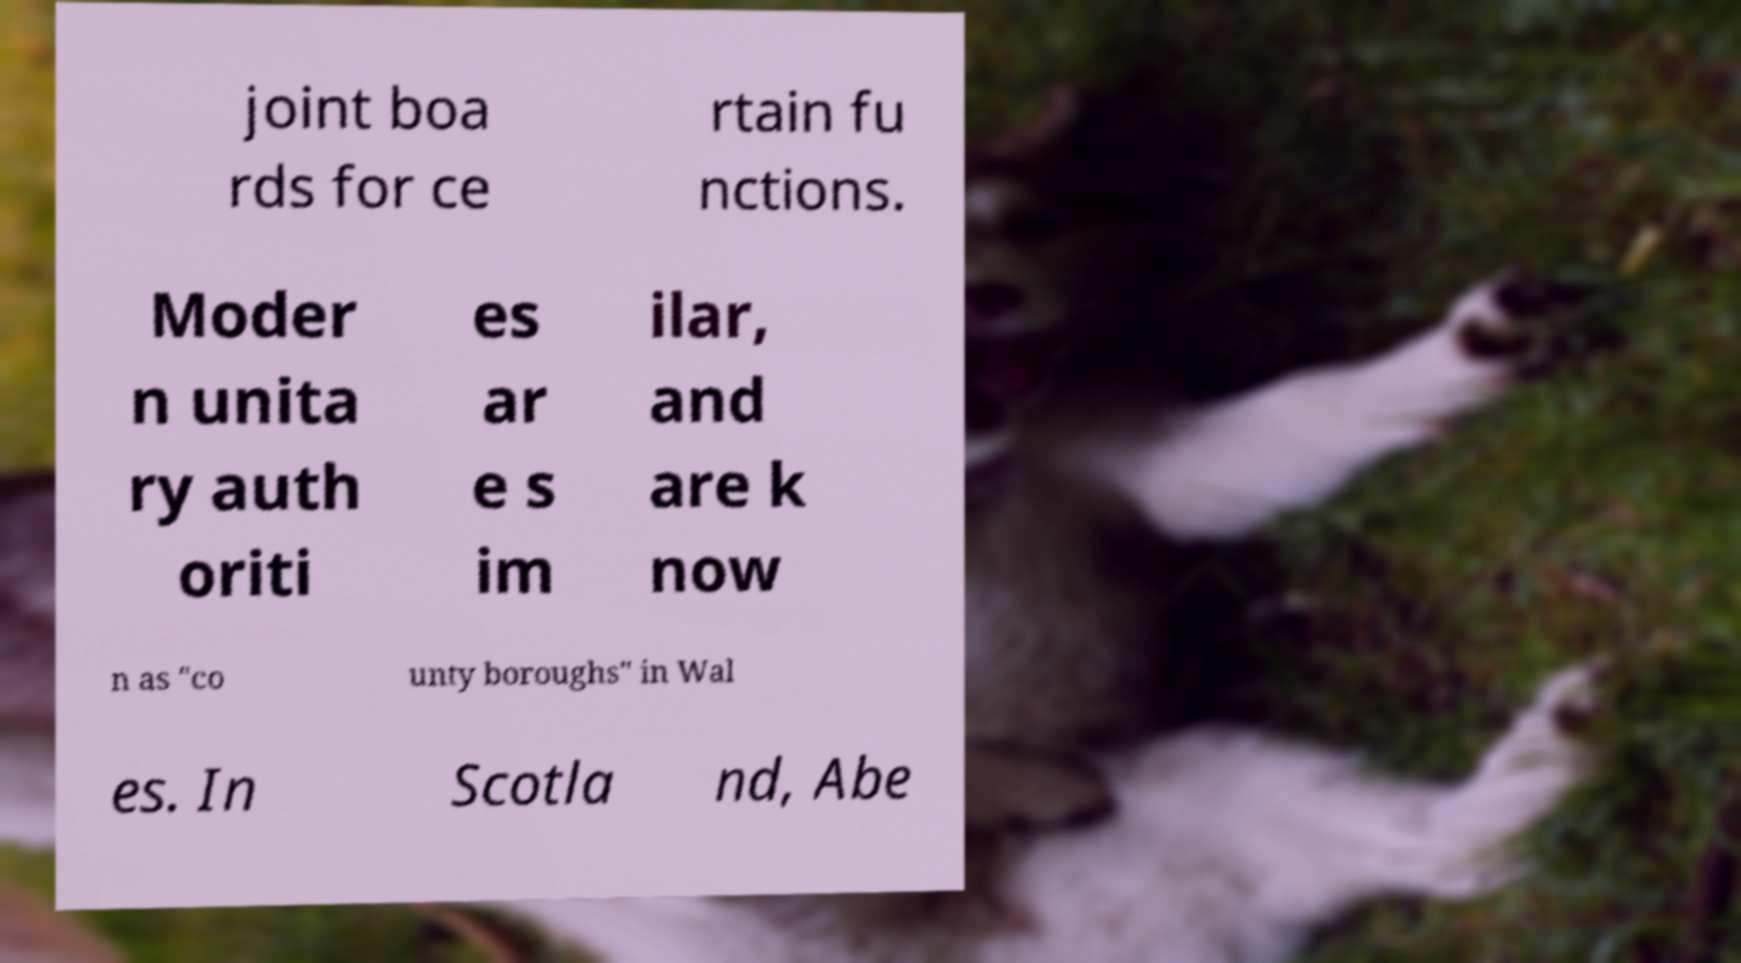Please read and relay the text visible in this image. What does it say? joint boa rds for ce rtain fu nctions. Moder n unita ry auth oriti es ar e s im ilar, and are k now n as "co unty boroughs" in Wal es. In Scotla nd, Abe 